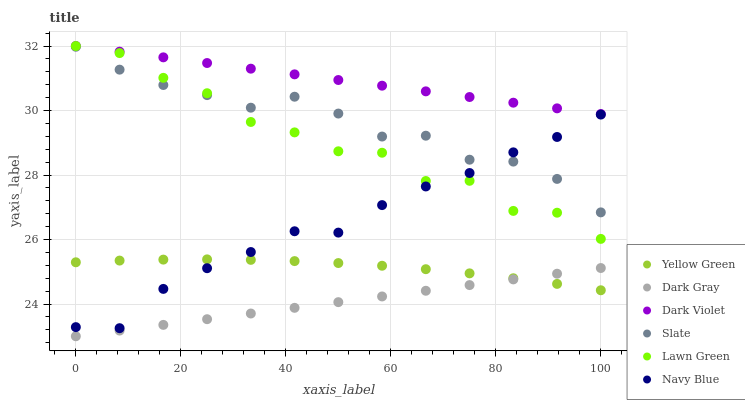Does Dark Gray have the minimum area under the curve?
Answer yes or no. Yes. Does Dark Violet have the maximum area under the curve?
Answer yes or no. Yes. Does Yellow Green have the minimum area under the curve?
Answer yes or no. No. Does Yellow Green have the maximum area under the curve?
Answer yes or no. No. Is Dark Violet the smoothest?
Answer yes or no. Yes. Is Lawn Green the roughest?
Answer yes or no. Yes. Is Yellow Green the smoothest?
Answer yes or no. No. Is Yellow Green the roughest?
Answer yes or no. No. Does Dark Gray have the lowest value?
Answer yes or no. Yes. Does Yellow Green have the lowest value?
Answer yes or no. No. Does Dark Violet have the highest value?
Answer yes or no. Yes. Does Yellow Green have the highest value?
Answer yes or no. No. Is Navy Blue less than Dark Violet?
Answer yes or no. Yes. Is Dark Violet greater than Dark Gray?
Answer yes or no. Yes. Does Lawn Green intersect Navy Blue?
Answer yes or no. Yes. Is Lawn Green less than Navy Blue?
Answer yes or no. No. Is Lawn Green greater than Navy Blue?
Answer yes or no. No. Does Navy Blue intersect Dark Violet?
Answer yes or no. No. 